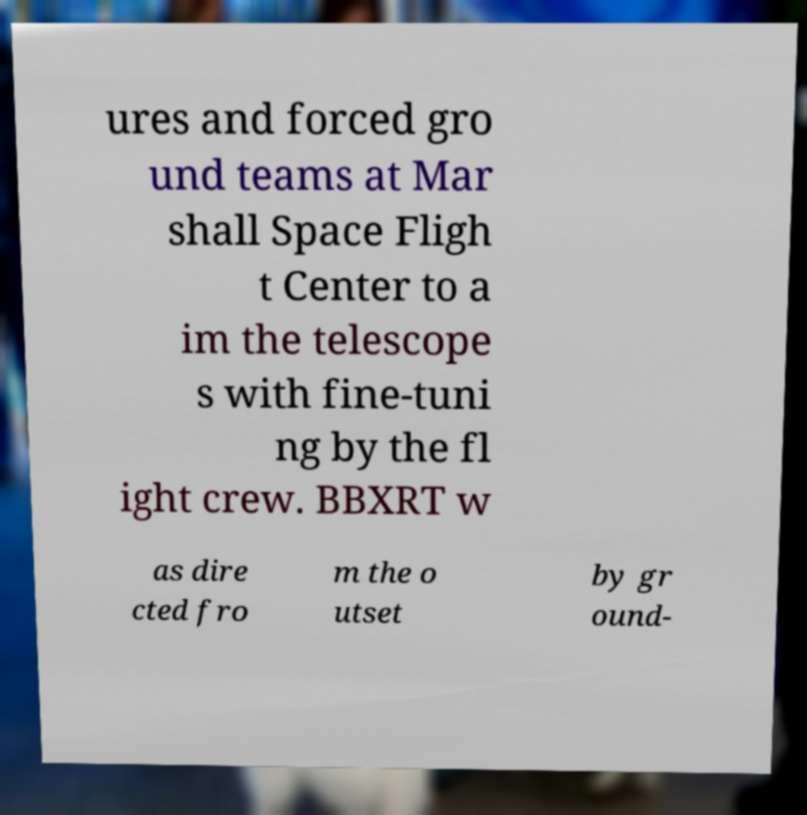Could you extract and type out the text from this image? ures and forced gro und teams at Mar shall Space Fligh t Center to a im the telescope s with fine-tuni ng by the fl ight crew. BBXRT w as dire cted fro m the o utset by gr ound- 